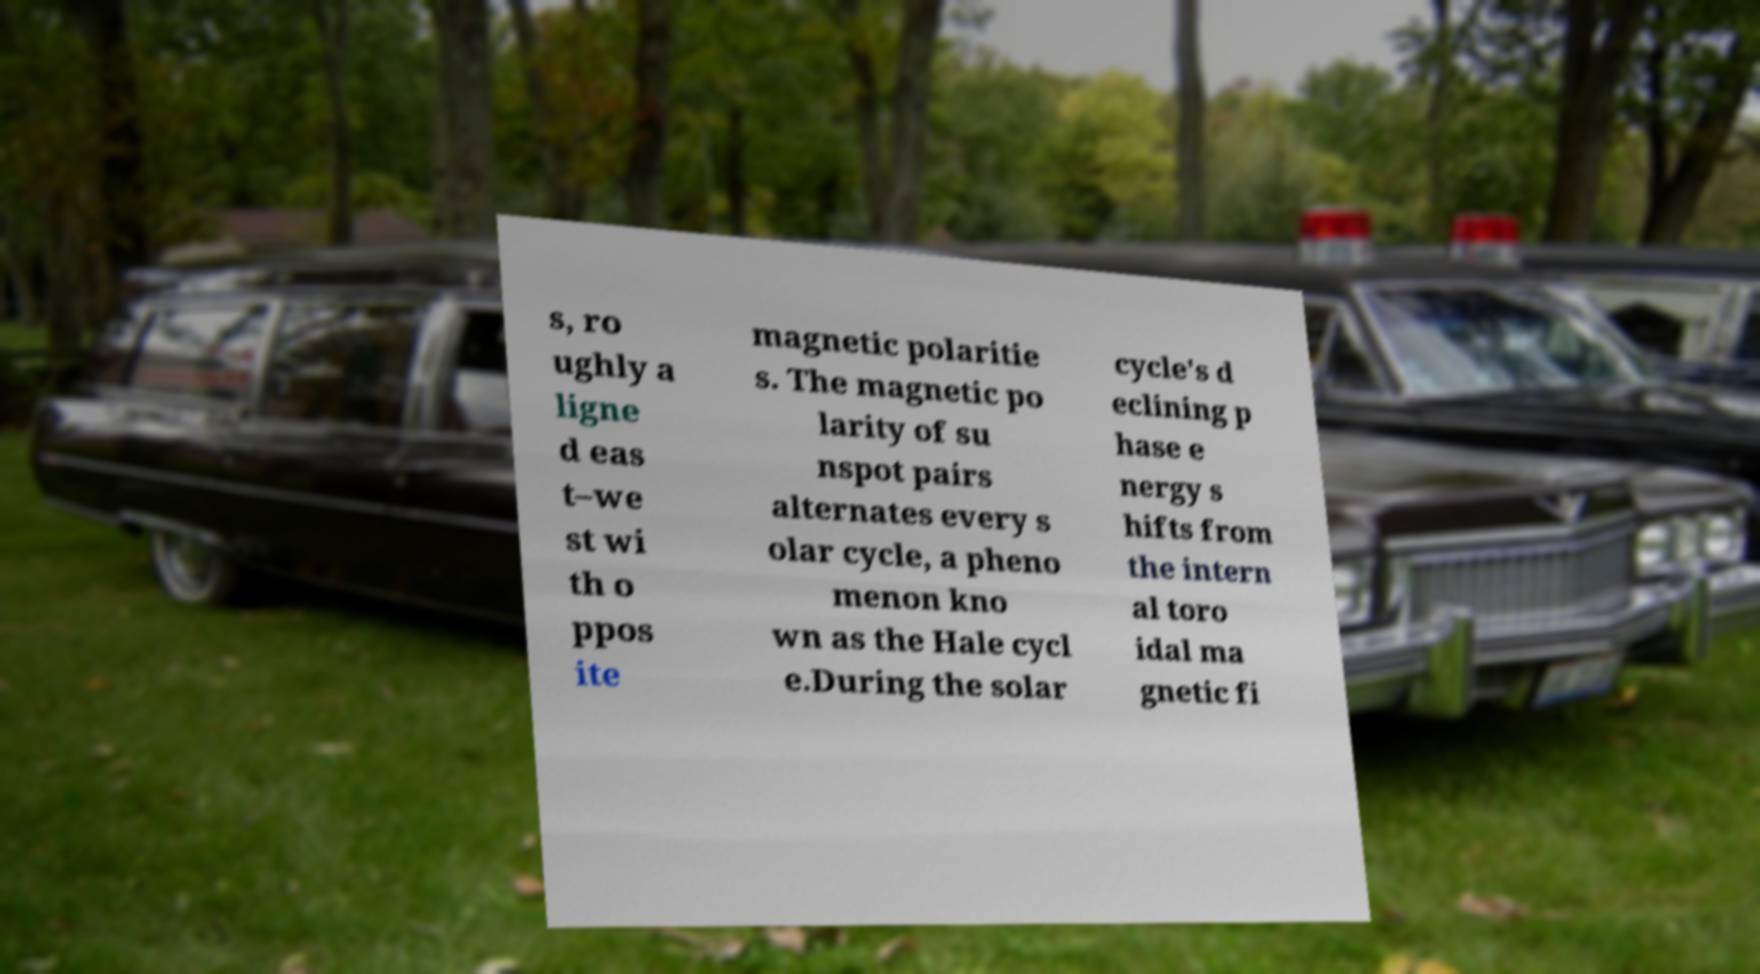For documentation purposes, I need the text within this image transcribed. Could you provide that? s, ro ughly a ligne d eas t–we st wi th o ppos ite magnetic polaritie s. The magnetic po larity of su nspot pairs alternates every s olar cycle, a pheno menon kno wn as the Hale cycl e.During the solar cycle's d eclining p hase e nergy s hifts from the intern al toro idal ma gnetic fi 